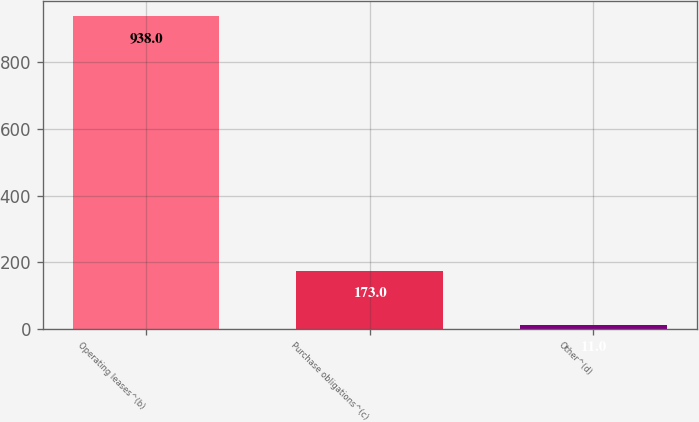Convert chart. <chart><loc_0><loc_0><loc_500><loc_500><bar_chart><fcel>Operating leases^(b)<fcel>Purchase obligations^(c)<fcel>Other^(d)<nl><fcel>938<fcel>173<fcel>11<nl></chart> 